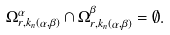Convert formula to latex. <formula><loc_0><loc_0><loc_500><loc_500>\Omega ^ { \alpha } _ { r , k _ { n } ( \alpha , \beta ) } \cap \Omega ^ { \beta } _ { r , k _ { n } ( \alpha , \beta ) } = \emptyset .</formula> 